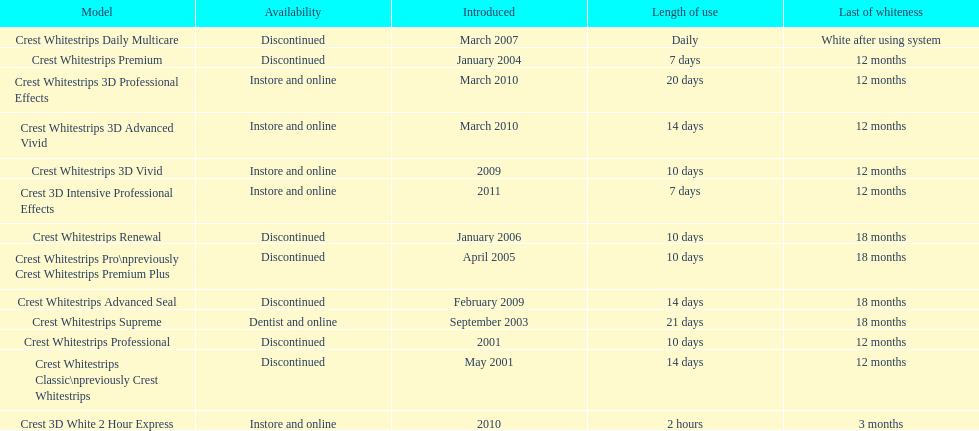Which product was to be used longer, crest whitestrips classic or crest whitestrips 3d vivid? Crest Whitestrips Classic. 